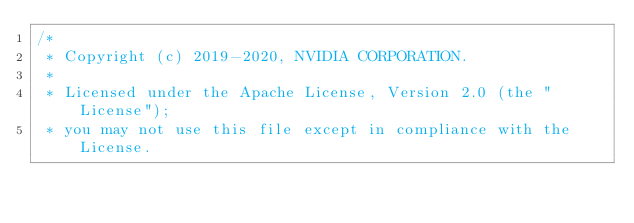Convert code to text. <code><loc_0><loc_0><loc_500><loc_500><_Cuda_>/*
 * Copyright (c) 2019-2020, NVIDIA CORPORATION.
 *
 * Licensed under the Apache License, Version 2.0 (the "License");
 * you may not use this file except in compliance with the License.</code> 